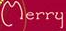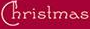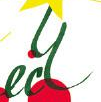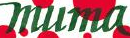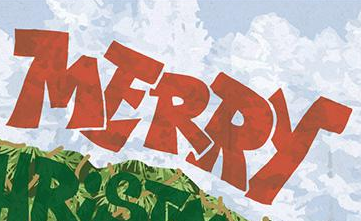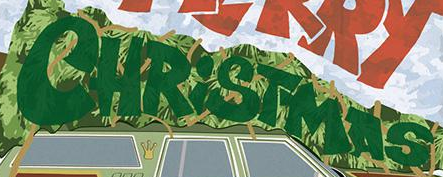What text is displayed in these images sequentially, separated by a semicolon? Merry; Christmas; ecy; muma; MERRY; CHRiSTMAS 